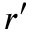Convert formula to latex. <formula><loc_0><loc_0><loc_500><loc_500>r ^ { \prime }</formula> 